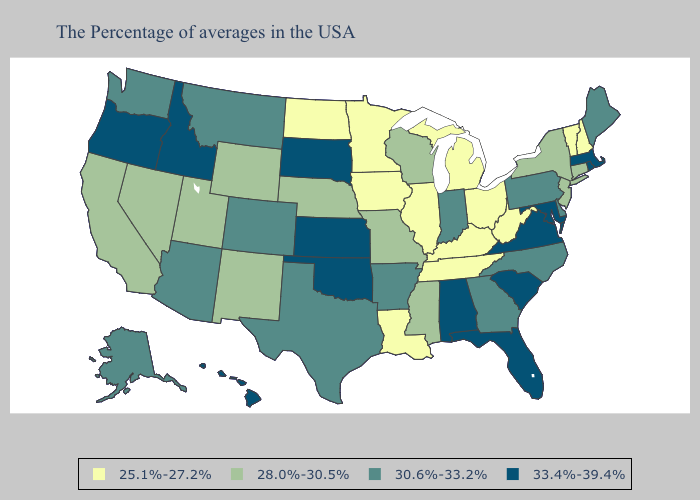What is the value of South Dakota?
Concise answer only. 33.4%-39.4%. Does Wisconsin have the highest value in the USA?
Keep it brief. No. Name the states that have a value in the range 30.6%-33.2%?
Answer briefly. Maine, Delaware, Pennsylvania, North Carolina, Georgia, Indiana, Arkansas, Texas, Colorado, Montana, Arizona, Washington, Alaska. Which states have the highest value in the USA?
Keep it brief. Massachusetts, Rhode Island, Maryland, Virginia, South Carolina, Florida, Alabama, Kansas, Oklahoma, South Dakota, Idaho, Oregon, Hawaii. Name the states that have a value in the range 33.4%-39.4%?
Keep it brief. Massachusetts, Rhode Island, Maryland, Virginia, South Carolina, Florida, Alabama, Kansas, Oklahoma, South Dakota, Idaho, Oregon, Hawaii. What is the value of West Virginia?
Answer briefly. 25.1%-27.2%. What is the highest value in states that border South Dakota?
Give a very brief answer. 30.6%-33.2%. Does Idaho have the highest value in the West?
Answer briefly. Yes. Which states hav the highest value in the South?
Keep it brief. Maryland, Virginia, South Carolina, Florida, Alabama, Oklahoma. Which states hav the highest value in the Northeast?
Answer briefly. Massachusetts, Rhode Island. What is the value of Arizona?
Keep it brief. 30.6%-33.2%. Does Maine have the same value as Delaware?
Be succinct. Yes. Among the states that border Idaho , does Oregon have the highest value?
Short answer required. Yes. Among the states that border Texas , which have the highest value?
Answer briefly. Oklahoma. Does Iowa have the lowest value in the MidWest?
Write a very short answer. Yes. 